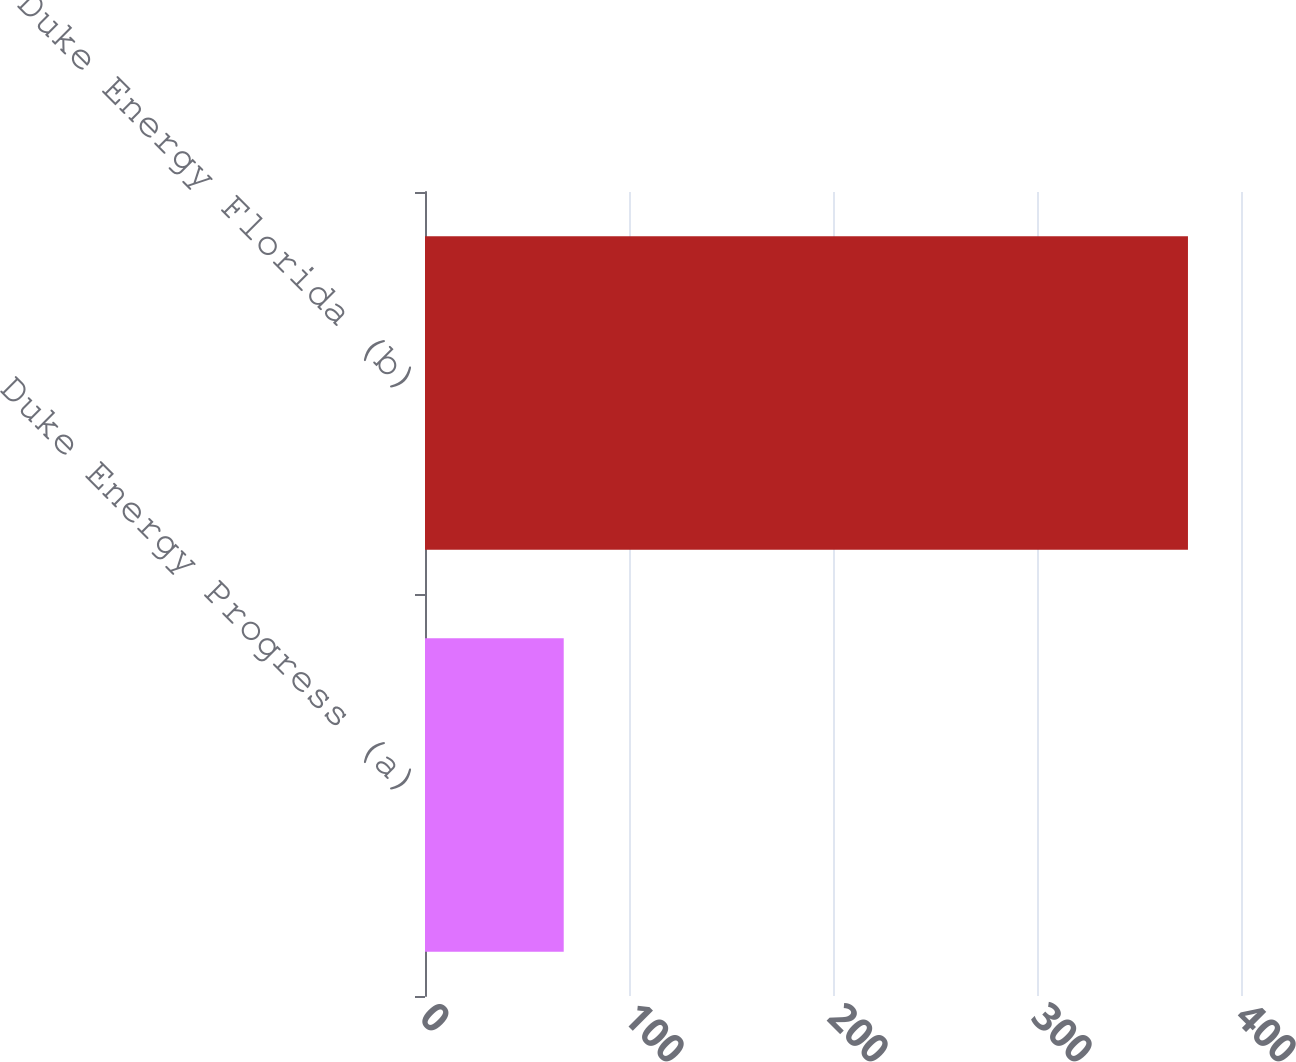<chart> <loc_0><loc_0><loc_500><loc_500><bar_chart><fcel>Duke Energy Progress (a)<fcel>Duke Energy Florida (b)<nl><fcel>68<fcel>374<nl></chart> 